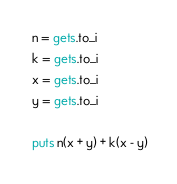Convert code to text. <code><loc_0><loc_0><loc_500><loc_500><_Ruby_> n = gets.to_i
 k = gets.to_i
 x = gets.to_i
 y = gets.to_i

 puts n(x + y) + k(x - y)</code> 